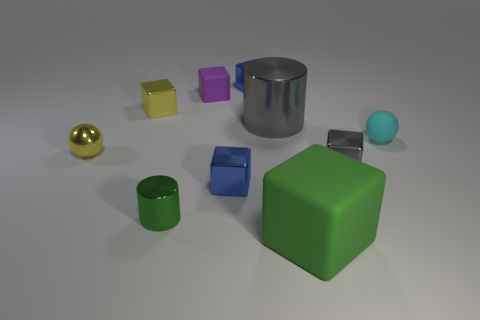Subtract all blue metallic blocks. How many blocks are left? 4 Subtract all purple cubes. How many cubes are left? 5 Subtract all cyan cubes. Subtract all purple cylinders. How many cubes are left? 6 Subtract all balls. How many objects are left? 8 Subtract 0 blue spheres. How many objects are left? 10 Subtract all tiny cyan spheres. Subtract all tiny purple rubber things. How many objects are left? 8 Add 2 small purple things. How many small purple things are left? 3 Add 3 blocks. How many blocks exist? 9 